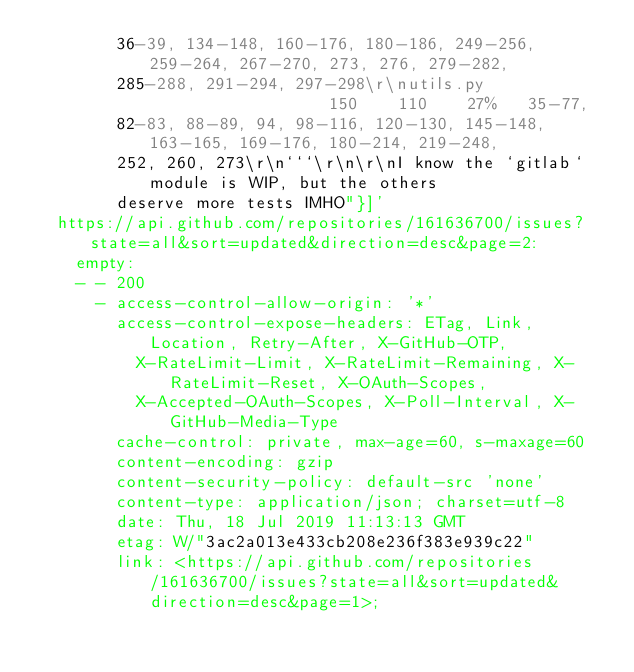Convert code to text. <code><loc_0><loc_0><loc_500><loc_500><_YAML_>        36-39, 134-148, 160-176, 180-186, 249-256, 259-264, 267-270, 273, 276, 279-282,
        285-288, 291-294, 297-298\r\nutils.py                   150    110    27%   35-77,
        82-83, 88-89, 94, 98-116, 120-130, 145-148, 163-165, 169-176, 180-214, 219-248,
        252, 260, 273\r\n```\r\n\r\nI know the `gitlab` module is WIP, but the others
        deserve more tests IMHO"}]'
  https://api.github.com/repositories/161636700/issues?state=all&sort=updated&direction=desc&page=2:
    empty:
    - - 200
      - access-control-allow-origin: '*'
        access-control-expose-headers: ETag, Link, Location, Retry-After, X-GitHub-OTP,
          X-RateLimit-Limit, X-RateLimit-Remaining, X-RateLimit-Reset, X-OAuth-Scopes,
          X-Accepted-OAuth-Scopes, X-Poll-Interval, X-GitHub-Media-Type
        cache-control: private, max-age=60, s-maxage=60
        content-encoding: gzip
        content-security-policy: default-src 'none'
        content-type: application/json; charset=utf-8
        date: Thu, 18 Jul 2019 11:13:13 GMT
        etag: W/"3ac2a013e433cb208e236f383e939c22"
        link: <https://api.github.com/repositories/161636700/issues?state=all&sort=updated&direction=desc&page=1>;</code> 